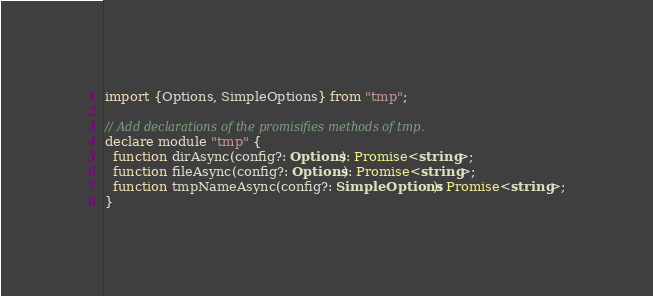<code> <loc_0><loc_0><loc_500><loc_500><_TypeScript_>import {Options, SimpleOptions} from "tmp";

// Add declarations of the promisifies methods of tmp.
declare module "tmp" {
  function dirAsync(config?: Options): Promise<string>;
  function fileAsync(config?: Options): Promise<string>;
  function tmpNameAsync(config?: SimpleOptions): Promise<string>;
}
</code> 